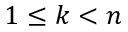Convert formula to latex. <formula><loc_0><loc_0><loc_500><loc_500>1 \leq k < n</formula> 